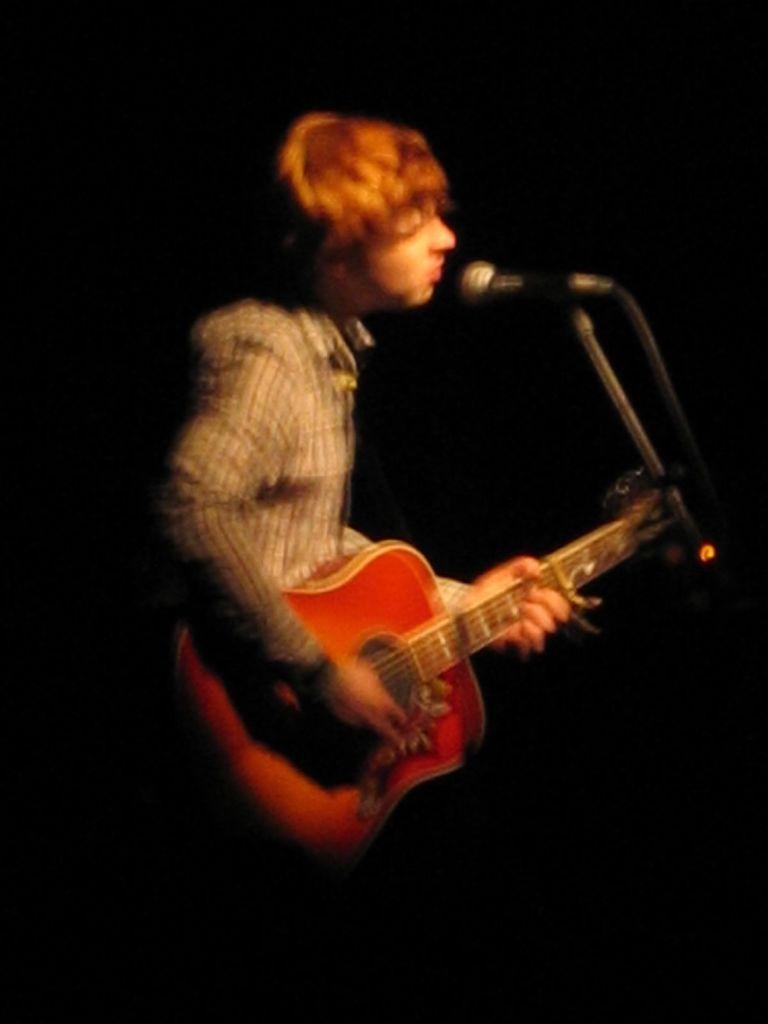Can you describe this image briefly? In this picture we can see man holding guitar and playing it and singing on mic and background it is dark. 